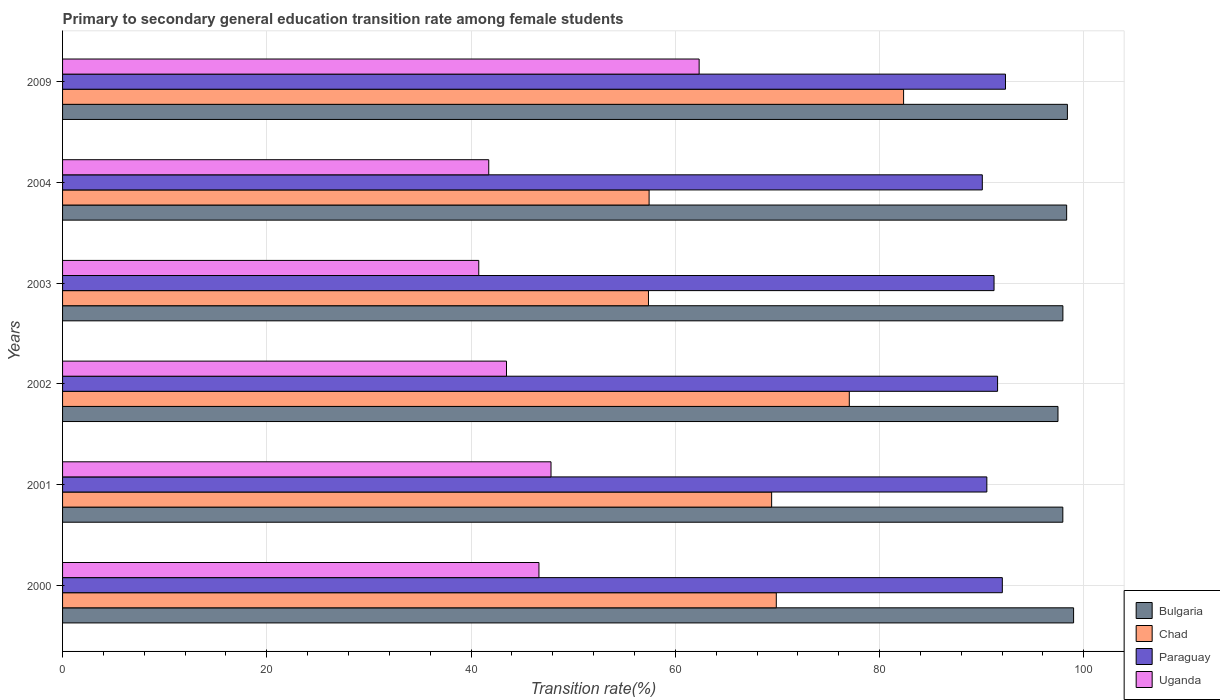How many different coloured bars are there?
Your answer should be very brief. 4. How many groups of bars are there?
Keep it short and to the point. 6. Are the number of bars on each tick of the Y-axis equal?
Keep it short and to the point. Yes. What is the label of the 2nd group of bars from the top?
Ensure brevity in your answer.  2004. In how many cases, is the number of bars for a given year not equal to the number of legend labels?
Give a very brief answer. 0. What is the transition rate in Paraguay in 2002?
Give a very brief answer. 91.55. Across all years, what is the maximum transition rate in Chad?
Make the answer very short. 82.35. Across all years, what is the minimum transition rate in Uganda?
Offer a terse response. 40.75. What is the total transition rate in Bulgaria in the graph?
Your answer should be compact. 589.07. What is the difference between the transition rate in Uganda in 2003 and that in 2004?
Give a very brief answer. -0.98. What is the difference between the transition rate in Paraguay in 2009 and the transition rate in Uganda in 2000?
Offer a very short reply. 45.68. What is the average transition rate in Chad per year?
Your response must be concise. 68.92. In the year 2001, what is the difference between the transition rate in Uganda and transition rate in Bulgaria?
Your answer should be compact. -50.12. What is the ratio of the transition rate in Chad in 2002 to that in 2004?
Offer a very short reply. 1.34. Is the transition rate in Chad in 2003 less than that in 2004?
Keep it short and to the point. Yes. What is the difference between the highest and the second highest transition rate in Bulgaria?
Offer a terse response. 0.61. What is the difference between the highest and the lowest transition rate in Bulgaria?
Provide a succinct answer. 1.53. In how many years, is the transition rate in Bulgaria greater than the average transition rate in Bulgaria taken over all years?
Make the answer very short. 3. Is the sum of the transition rate in Chad in 2001 and 2003 greater than the maximum transition rate in Bulgaria across all years?
Keep it short and to the point. Yes. Is it the case that in every year, the sum of the transition rate in Bulgaria and transition rate in Chad is greater than the sum of transition rate in Paraguay and transition rate in Uganda?
Offer a very short reply. No. What does the 4th bar from the top in 2004 represents?
Provide a short and direct response. Bulgaria. Is it the case that in every year, the sum of the transition rate in Uganda and transition rate in Bulgaria is greater than the transition rate in Paraguay?
Provide a short and direct response. Yes. How many bars are there?
Your response must be concise. 24. Are all the bars in the graph horizontal?
Make the answer very short. Yes. How many years are there in the graph?
Provide a succinct answer. 6. What is the difference between two consecutive major ticks on the X-axis?
Ensure brevity in your answer.  20. Does the graph contain grids?
Your answer should be compact. Yes. How many legend labels are there?
Your answer should be compact. 4. How are the legend labels stacked?
Give a very brief answer. Vertical. What is the title of the graph?
Provide a short and direct response. Primary to secondary general education transition rate among female students. Does "Saudi Arabia" appear as one of the legend labels in the graph?
Offer a terse response. No. What is the label or title of the X-axis?
Your answer should be very brief. Transition rate(%). What is the Transition rate(%) of Bulgaria in 2000?
Provide a succinct answer. 99. What is the Transition rate(%) in Chad in 2000?
Your answer should be compact. 69.89. What is the Transition rate(%) in Paraguay in 2000?
Your answer should be compact. 92.02. What is the Transition rate(%) in Uganda in 2000?
Your answer should be very brief. 46.65. What is the Transition rate(%) in Bulgaria in 2001?
Your answer should be compact. 97.94. What is the Transition rate(%) of Chad in 2001?
Provide a short and direct response. 69.43. What is the Transition rate(%) of Paraguay in 2001?
Your response must be concise. 90.5. What is the Transition rate(%) of Uganda in 2001?
Ensure brevity in your answer.  47.83. What is the Transition rate(%) of Bulgaria in 2002?
Your answer should be very brief. 97.47. What is the Transition rate(%) of Chad in 2002?
Ensure brevity in your answer.  77.03. What is the Transition rate(%) in Paraguay in 2002?
Offer a very short reply. 91.55. What is the Transition rate(%) in Uganda in 2002?
Make the answer very short. 43.47. What is the Transition rate(%) in Bulgaria in 2003?
Ensure brevity in your answer.  97.95. What is the Transition rate(%) in Chad in 2003?
Keep it short and to the point. 57.37. What is the Transition rate(%) of Paraguay in 2003?
Your response must be concise. 91.21. What is the Transition rate(%) of Uganda in 2003?
Ensure brevity in your answer.  40.75. What is the Transition rate(%) of Bulgaria in 2004?
Provide a short and direct response. 98.32. What is the Transition rate(%) in Chad in 2004?
Your answer should be compact. 57.43. What is the Transition rate(%) in Paraguay in 2004?
Your answer should be very brief. 90.06. What is the Transition rate(%) of Uganda in 2004?
Your answer should be very brief. 41.73. What is the Transition rate(%) of Bulgaria in 2009?
Your answer should be very brief. 98.39. What is the Transition rate(%) in Chad in 2009?
Keep it short and to the point. 82.35. What is the Transition rate(%) in Paraguay in 2009?
Give a very brief answer. 92.33. What is the Transition rate(%) in Uganda in 2009?
Keep it short and to the point. 62.33. Across all years, what is the maximum Transition rate(%) in Bulgaria?
Your answer should be compact. 99. Across all years, what is the maximum Transition rate(%) in Chad?
Your answer should be very brief. 82.35. Across all years, what is the maximum Transition rate(%) in Paraguay?
Provide a short and direct response. 92.33. Across all years, what is the maximum Transition rate(%) of Uganda?
Offer a very short reply. 62.33. Across all years, what is the minimum Transition rate(%) of Bulgaria?
Make the answer very short. 97.47. Across all years, what is the minimum Transition rate(%) in Chad?
Provide a succinct answer. 57.37. Across all years, what is the minimum Transition rate(%) of Paraguay?
Offer a very short reply. 90.06. Across all years, what is the minimum Transition rate(%) of Uganda?
Offer a very short reply. 40.75. What is the total Transition rate(%) in Bulgaria in the graph?
Your answer should be very brief. 589.07. What is the total Transition rate(%) in Chad in the graph?
Ensure brevity in your answer.  413.51. What is the total Transition rate(%) in Paraguay in the graph?
Provide a short and direct response. 547.67. What is the total Transition rate(%) in Uganda in the graph?
Your response must be concise. 282.76. What is the difference between the Transition rate(%) of Bulgaria in 2000 and that in 2001?
Give a very brief answer. 1.05. What is the difference between the Transition rate(%) of Chad in 2000 and that in 2001?
Provide a short and direct response. 0.46. What is the difference between the Transition rate(%) of Paraguay in 2000 and that in 2001?
Provide a succinct answer. 1.52. What is the difference between the Transition rate(%) in Uganda in 2000 and that in 2001?
Your response must be concise. -1.18. What is the difference between the Transition rate(%) in Bulgaria in 2000 and that in 2002?
Provide a succinct answer. 1.53. What is the difference between the Transition rate(%) in Chad in 2000 and that in 2002?
Provide a short and direct response. -7.15. What is the difference between the Transition rate(%) of Paraguay in 2000 and that in 2002?
Offer a very short reply. 0.46. What is the difference between the Transition rate(%) in Uganda in 2000 and that in 2002?
Your response must be concise. 3.18. What is the difference between the Transition rate(%) of Bulgaria in 2000 and that in 2003?
Ensure brevity in your answer.  1.05. What is the difference between the Transition rate(%) of Chad in 2000 and that in 2003?
Give a very brief answer. 12.52. What is the difference between the Transition rate(%) in Paraguay in 2000 and that in 2003?
Make the answer very short. 0.81. What is the difference between the Transition rate(%) in Uganda in 2000 and that in 2003?
Your answer should be compact. 5.89. What is the difference between the Transition rate(%) in Bulgaria in 2000 and that in 2004?
Make the answer very short. 0.68. What is the difference between the Transition rate(%) in Chad in 2000 and that in 2004?
Your response must be concise. 12.46. What is the difference between the Transition rate(%) of Paraguay in 2000 and that in 2004?
Provide a succinct answer. 1.96. What is the difference between the Transition rate(%) of Uganda in 2000 and that in 2004?
Your answer should be very brief. 4.92. What is the difference between the Transition rate(%) in Bulgaria in 2000 and that in 2009?
Provide a short and direct response. 0.61. What is the difference between the Transition rate(%) in Chad in 2000 and that in 2009?
Your answer should be very brief. -12.46. What is the difference between the Transition rate(%) in Paraguay in 2000 and that in 2009?
Make the answer very short. -0.31. What is the difference between the Transition rate(%) in Uganda in 2000 and that in 2009?
Your answer should be compact. -15.69. What is the difference between the Transition rate(%) of Bulgaria in 2001 and that in 2002?
Your answer should be very brief. 0.47. What is the difference between the Transition rate(%) in Chad in 2001 and that in 2002?
Provide a succinct answer. -7.6. What is the difference between the Transition rate(%) of Paraguay in 2001 and that in 2002?
Provide a succinct answer. -1.05. What is the difference between the Transition rate(%) of Uganda in 2001 and that in 2002?
Make the answer very short. 4.36. What is the difference between the Transition rate(%) of Bulgaria in 2001 and that in 2003?
Make the answer very short. -0.01. What is the difference between the Transition rate(%) in Chad in 2001 and that in 2003?
Give a very brief answer. 12.06. What is the difference between the Transition rate(%) in Paraguay in 2001 and that in 2003?
Offer a terse response. -0.7. What is the difference between the Transition rate(%) in Uganda in 2001 and that in 2003?
Provide a succinct answer. 7.07. What is the difference between the Transition rate(%) of Bulgaria in 2001 and that in 2004?
Keep it short and to the point. -0.37. What is the difference between the Transition rate(%) of Chad in 2001 and that in 2004?
Your response must be concise. 12. What is the difference between the Transition rate(%) in Paraguay in 2001 and that in 2004?
Your answer should be compact. 0.44. What is the difference between the Transition rate(%) of Uganda in 2001 and that in 2004?
Ensure brevity in your answer.  6.1. What is the difference between the Transition rate(%) in Bulgaria in 2001 and that in 2009?
Offer a very short reply. -0.45. What is the difference between the Transition rate(%) of Chad in 2001 and that in 2009?
Provide a short and direct response. -12.92. What is the difference between the Transition rate(%) of Paraguay in 2001 and that in 2009?
Make the answer very short. -1.82. What is the difference between the Transition rate(%) of Uganda in 2001 and that in 2009?
Your answer should be very brief. -14.5. What is the difference between the Transition rate(%) in Bulgaria in 2002 and that in 2003?
Your response must be concise. -0.48. What is the difference between the Transition rate(%) in Chad in 2002 and that in 2003?
Keep it short and to the point. 19.66. What is the difference between the Transition rate(%) of Paraguay in 2002 and that in 2003?
Provide a succinct answer. 0.35. What is the difference between the Transition rate(%) in Uganda in 2002 and that in 2003?
Offer a very short reply. 2.72. What is the difference between the Transition rate(%) in Bulgaria in 2002 and that in 2004?
Offer a terse response. -0.85. What is the difference between the Transition rate(%) of Chad in 2002 and that in 2004?
Provide a short and direct response. 19.6. What is the difference between the Transition rate(%) in Paraguay in 2002 and that in 2004?
Make the answer very short. 1.49. What is the difference between the Transition rate(%) of Uganda in 2002 and that in 2004?
Keep it short and to the point. 1.74. What is the difference between the Transition rate(%) of Bulgaria in 2002 and that in 2009?
Offer a terse response. -0.92. What is the difference between the Transition rate(%) of Chad in 2002 and that in 2009?
Ensure brevity in your answer.  -5.32. What is the difference between the Transition rate(%) of Paraguay in 2002 and that in 2009?
Your response must be concise. -0.77. What is the difference between the Transition rate(%) in Uganda in 2002 and that in 2009?
Your response must be concise. -18.86. What is the difference between the Transition rate(%) of Bulgaria in 2003 and that in 2004?
Provide a short and direct response. -0.37. What is the difference between the Transition rate(%) of Chad in 2003 and that in 2004?
Your answer should be compact. -0.06. What is the difference between the Transition rate(%) in Paraguay in 2003 and that in 2004?
Your answer should be compact. 1.15. What is the difference between the Transition rate(%) in Uganda in 2003 and that in 2004?
Provide a succinct answer. -0.98. What is the difference between the Transition rate(%) in Bulgaria in 2003 and that in 2009?
Provide a succinct answer. -0.44. What is the difference between the Transition rate(%) of Chad in 2003 and that in 2009?
Your response must be concise. -24.98. What is the difference between the Transition rate(%) of Paraguay in 2003 and that in 2009?
Make the answer very short. -1.12. What is the difference between the Transition rate(%) in Uganda in 2003 and that in 2009?
Offer a terse response. -21.58. What is the difference between the Transition rate(%) of Bulgaria in 2004 and that in 2009?
Provide a succinct answer. -0.07. What is the difference between the Transition rate(%) in Chad in 2004 and that in 2009?
Your answer should be compact. -24.92. What is the difference between the Transition rate(%) in Paraguay in 2004 and that in 2009?
Keep it short and to the point. -2.27. What is the difference between the Transition rate(%) of Uganda in 2004 and that in 2009?
Offer a terse response. -20.6. What is the difference between the Transition rate(%) of Bulgaria in 2000 and the Transition rate(%) of Chad in 2001?
Ensure brevity in your answer.  29.57. What is the difference between the Transition rate(%) in Bulgaria in 2000 and the Transition rate(%) in Paraguay in 2001?
Keep it short and to the point. 8.49. What is the difference between the Transition rate(%) in Bulgaria in 2000 and the Transition rate(%) in Uganda in 2001?
Provide a short and direct response. 51.17. What is the difference between the Transition rate(%) in Chad in 2000 and the Transition rate(%) in Paraguay in 2001?
Give a very brief answer. -20.62. What is the difference between the Transition rate(%) of Chad in 2000 and the Transition rate(%) of Uganda in 2001?
Your answer should be compact. 22.06. What is the difference between the Transition rate(%) in Paraguay in 2000 and the Transition rate(%) in Uganda in 2001?
Keep it short and to the point. 44.19. What is the difference between the Transition rate(%) of Bulgaria in 2000 and the Transition rate(%) of Chad in 2002?
Offer a very short reply. 21.96. What is the difference between the Transition rate(%) of Bulgaria in 2000 and the Transition rate(%) of Paraguay in 2002?
Give a very brief answer. 7.44. What is the difference between the Transition rate(%) in Bulgaria in 2000 and the Transition rate(%) in Uganda in 2002?
Keep it short and to the point. 55.53. What is the difference between the Transition rate(%) of Chad in 2000 and the Transition rate(%) of Paraguay in 2002?
Provide a succinct answer. -21.67. What is the difference between the Transition rate(%) in Chad in 2000 and the Transition rate(%) in Uganda in 2002?
Your answer should be very brief. 26.42. What is the difference between the Transition rate(%) of Paraguay in 2000 and the Transition rate(%) of Uganda in 2002?
Offer a terse response. 48.55. What is the difference between the Transition rate(%) in Bulgaria in 2000 and the Transition rate(%) in Chad in 2003?
Your answer should be very brief. 41.63. What is the difference between the Transition rate(%) of Bulgaria in 2000 and the Transition rate(%) of Paraguay in 2003?
Provide a short and direct response. 7.79. What is the difference between the Transition rate(%) of Bulgaria in 2000 and the Transition rate(%) of Uganda in 2003?
Offer a terse response. 58.24. What is the difference between the Transition rate(%) in Chad in 2000 and the Transition rate(%) in Paraguay in 2003?
Your answer should be compact. -21.32. What is the difference between the Transition rate(%) of Chad in 2000 and the Transition rate(%) of Uganda in 2003?
Keep it short and to the point. 29.13. What is the difference between the Transition rate(%) in Paraguay in 2000 and the Transition rate(%) in Uganda in 2003?
Provide a succinct answer. 51.27. What is the difference between the Transition rate(%) in Bulgaria in 2000 and the Transition rate(%) in Chad in 2004?
Provide a short and direct response. 41.57. What is the difference between the Transition rate(%) in Bulgaria in 2000 and the Transition rate(%) in Paraguay in 2004?
Your answer should be compact. 8.94. What is the difference between the Transition rate(%) of Bulgaria in 2000 and the Transition rate(%) of Uganda in 2004?
Ensure brevity in your answer.  57.27. What is the difference between the Transition rate(%) in Chad in 2000 and the Transition rate(%) in Paraguay in 2004?
Offer a very short reply. -20.17. What is the difference between the Transition rate(%) in Chad in 2000 and the Transition rate(%) in Uganda in 2004?
Offer a terse response. 28.16. What is the difference between the Transition rate(%) of Paraguay in 2000 and the Transition rate(%) of Uganda in 2004?
Offer a terse response. 50.29. What is the difference between the Transition rate(%) of Bulgaria in 2000 and the Transition rate(%) of Chad in 2009?
Provide a short and direct response. 16.65. What is the difference between the Transition rate(%) in Bulgaria in 2000 and the Transition rate(%) in Paraguay in 2009?
Provide a succinct answer. 6.67. What is the difference between the Transition rate(%) in Bulgaria in 2000 and the Transition rate(%) in Uganda in 2009?
Your answer should be compact. 36.67. What is the difference between the Transition rate(%) of Chad in 2000 and the Transition rate(%) of Paraguay in 2009?
Give a very brief answer. -22.44. What is the difference between the Transition rate(%) in Chad in 2000 and the Transition rate(%) in Uganda in 2009?
Your response must be concise. 7.56. What is the difference between the Transition rate(%) of Paraguay in 2000 and the Transition rate(%) of Uganda in 2009?
Give a very brief answer. 29.69. What is the difference between the Transition rate(%) of Bulgaria in 2001 and the Transition rate(%) of Chad in 2002?
Give a very brief answer. 20.91. What is the difference between the Transition rate(%) of Bulgaria in 2001 and the Transition rate(%) of Paraguay in 2002?
Your answer should be compact. 6.39. What is the difference between the Transition rate(%) in Bulgaria in 2001 and the Transition rate(%) in Uganda in 2002?
Your answer should be compact. 54.47. What is the difference between the Transition rate(%) of Chad in 2001 and the Transition rate(%) of Paraguay in 2002?
Your response must be concise. -22.12. What is the difference between the Transition rate(%) of Chad in 2001 and the Transition rate(%) of Uganda in 2002?
Make the answer very short. 25.96. What is the difference between the Transition rate(%) in Paraguay in 2001 and the Transition rate(%) in Uganda in 2002?
Offer a terse response. 47.03. What is the difference between the Transition rate(%) in Bulgaria in 2001 and the Transition rate(%) in Chad in 2003?
Keep it short and to the point. 40.57. What is the difference between the Transition rate(%) of Bulgaria in 2001 and the Transition rate(%) of Paraguay in 2003?
Provide a short and direct response. 6.74. What is the difference between the Transition rate(%) of Bulgaria in 2001 and the Transition rate(%) of Uganda in 2003?
Offer a very short reply. 57.19. What is the difference between the Transition rate(%) of Chad in 2001 and the Transition rate(%) of Paraguay in 2003?
Ensure brevity in your answer.  -21.78. What is the difference between the Transition rate(%) of Chad in 2001 and the Transition rate(%) of Uganda in 2003?
Ensure brevity in your answer.  28.68. What is the difference between the Transition rate(%) of Paraguay in 2001 and the Transition rate(%) of Uganda in 2003?
Provide a succinct answer. 49.75. What is the difference between the Transition rate(%) in Bulgaria in 2001 and the Transition rate(%) in Chad in 2004?
Make the answer very short. 40.51. What is the difference between the Transition rate(%) in Bulgaria in 2001 and the Transition rate(%) in Paraguay in 2004?
Give a very brief answer. 7.88. What is the difference between the Transition rate(%) of Bulgaria in 2001 and the Transition rate(%) of Uganda in 2004?
Provide a short and direct response. 56.21. What is the difference between the Transition rate(%) in Chad in 2001 and the Transition rate(%) in Paraguay in 2004?
Offer a terse response. -20.63. What is the difference between the Transition rate(%) of Chad in 2001 and the Transition rate(%) of Uganda in 2004?
Provide a succinct answer. 27.7. What is the difference between the Transition rate(%) in Paraguay in 2001 and the Transition rate(%) in Uganda in 2004?
Make the answer very short. 48.77. What is the difference between the Transition rate(%) in Bulgaria in 2001 and the Transition rate(%) in Chad in 2009?
Offer a very short reply. 15.59. What is the difference between the Transition rate(%) of Bulgaria in 2001 and the Transition rate(%) of Paraguay in 2009?
Offer a terse response. 5.62. What is the difference between the Transition rate(%) in Bulgaria in 2001 and the Transition rate(%) in Uganda in 2009?
Offer a terse response. 35.61. What is the difference between the Transition rate(%) in Chad in 2001 and the Transition rate(%) in Paraguay in 2009?
Your answer should be compact. -22.9. What is the difference between the Transition rate(%) of Chad in 2001 and the Transition rate(%) of Uganda in 2009?
Offer a terse response. 7.1. What is the difference between the Transition rate(%) in Paraguay in 2001 and the Transition rate(%) in Uganda in 2009?
Keep it short and to the point. 28.17. What is the difference between the Transition rate(%) of Bulgaria in 2002 and the Transition rate(%) of Chad in 2003?
Give a very brief answer. 40.1. What is the difference between the Transition rate(%) of Bulgaria in 2002 and the Transition rate(%) of Paraguay in 2003?
Ensure brevity in your answer.  6.26. What is the difference between the Transition rate(%) in Bulgaria in 2002 and the Transition rate(%) in Uganda in 2003?
Provide a short and direct response. 56.72. What is the difference between the Transition rate(%) of Chad in 2002 and the Transition rate(%) of Paraguay in 2003?
Give a very brief answer. -14.17. What is the difference between the Transition rate(%) of Chad in 2002 and the Transition rate(%) of Uganda in 2003?
Keep it short and to the point. 36.28. What is the difference between the Transition rate(%) in Paraguay in 2002 and the Transition rate(%) in Uganda in 2003?
Keep it short and to the point. 50.8. What is the difference between the Transition rate(%) in Bulgaria in 2002 and the Transition rate(%) in Chad in 2004?
Your answer should be compact. 40.04. What is the difference between the Transition rate(%) of Bulgaria in 2002 and the Transition rate(%) of Paraguay in 2004?
Your response must be concise. 7.41. What is the difference between the Transition rate(%) in Bulgaria in 2002 and the Transition rate(%) in Uganda in 2004?
Keep it short and to the point. 55.74. What is the difference between the Transition rate(%) in Chad in 2002 and the Transition rate(%) in Paraguay in 2004?
Offer a very short reply. -13.03. What is the difference between the Transition rate(%) of Chad in 2002 and the Transition rate(%) of Uganda in 2004?
Your response must be concise. 35.3. What is the difference between the Transition rate(%) in Paraguay in 2002 and the Transition rate(%) in Uganda in 2004?
Your response must be concise. 49.82. What is the difference between the Transition rate(%) of Bulgaria in 2002 and the Transition rate(%) of Chad in 2009?
Give a very brief answer. 15.12. What is the difference between the Transition rate(%) in Bulgaria in 2002 and the Transition rate(%) in Paraguay in 2009?
Ensure brevity in your answer.  5.14. What is the difference between the Transition rate(%) of Bulgaria in 2002 and the Transition rate(%) of Uganda in 2009?
Give a very brief answer. 35.14. What is the difference between the Transition rate(%) in Chad in 2002 and the Transition rate(%) in Paraguay in 2009?
Provide a succinct answer. -15.29. What is the difference between the Transition rate(%) in Chad in 2002 and the Transition rate(%) in Uganda in 2009?
Make the answer very short. 14.7. What is the difference between the Transition rate(%) in Paraguay in 2002 and the Transition rate(%) in Uganda in 2009?
Make the answer very short. 29.22. What is the difference between the Transition rate(%) in Bulgaria in 2003 and the Transition rate(%) in Chad in 2004?
Your answer should be very brief. 40.52. What is the difference between the Transition rate(%) in Bulgaria in 2003 and the Transition rate(%) in Paraguay in 2004?
Provide a short and direct response. 7.89. What is the difference between the Transition rate(%) of Bulgaria in 2003 and the Transition rate(%) of Uganda in 2004?
Make the answer very short. 56.22. What is the difference between the Transition rate(%) in Chad in 2003 and the Transition rate(%) in Paraguay in 2004?
Provide a short and direct response. -32.69. What is the difference between the Transition rate(%) in Chad in 2003 and the Transition rate(%) in Uganda in 2004?
Offer a terse response. 15.64. What is the difference between the Transition rate(%) of Paraguay in 2003 and the Transition rate(%) of Uganda in 2004?
Make the answer very short. 49.48. What is the difference between the Transition rate(%) of Bulgaria in 2003 and the Transition rate(%) of Chad in 2009?
Offer a terse response. 15.6. What is the difference between the Transition rate(%) in Bulgaria in 2003 and the Transition rate(%) in Paraguay in 2009?
Provide a succinct answer. 5.62. What is the difference between the Transition rate(%) of Bulgaria in 2003 and the Transition rate(%) of Uganda in 2009?
Your answer should be compact. 35.62. What is the difference between the Transition rate(%) in Chad in 2003 and the Transition rate(%) in Paraguay in 2009?
Make the answer very short. -34.96. What is the difference between the Transition rate(%) in Chad in 2003 and the Transition rate(%) in Uganda in 2009?
Your response must be concise. -4.96. What is the difference between the Transition rate(%) of Paraguay in 2003 and the Transition rate(%) of Uganda in 2009?
Offer a terse response. 28.88. What is the difference between the Transition rate(%) in Bulgaria in 2004 and the Transition rate(%) in Chad in 2009?
Keep it short and to the point. 15.97. What is the difference between the Transition rate(%) of Bulgaria in 2004 and the Transition rate(%) of Paraguay in 2009?
Offer a very short reply. 5.99. What is the difference between the Transition rate(%) of Bulgaria in 2004 and the Transition rate(%) of Uganda in 2009?
Your answer should be very brief. 35.99. What is the difference between the Transition rate(%) of Chad in 2004 and the Transition rate(%) of Paraguay in 2009?
Give a very brief answer. -34.9. What is the difference between the Transition rate(%) of Chad in 2004 and the Transition rate(%) of Uganda in 2009?
Give a very brief answer. -4.9. What is the difference between the Transition rate(%) in Paraguay in 2004 and the Transition rate(%) in Uganda in 2009?
Provide a succinct answer. 27.73. What is the average Transition rate(%) of Bulgaria per year?
Make the answer very short. 98.18. What is the average Transition rate(%) of Chad per year?
Offer a very short reply. 68.92. What is the average Transition rate(%) of Paraguay per year?
Ensure brevity in your answer.  91.28. What is the average Transition rate(%) of Uganda per year?
Your answer should be very brief. 47.13. In the year 2000, what is the difference between the Transition rate(%) of Bulgaria and Transition rate(%) of Chad?
Offer a terse response. 29.11. In the year 2000, what is the difference between the Transition rate(%) of Bulgaria and Transition rate(%) of Paraguay?
Provide a succinct answer. 6.98. In the year 2000, what is the difference between the Transition rate(%) of Bulgaria and Transition rate(%) of Uganda?
Provide a short and direct response. 52.35. In the year 2000, what is the difference between the Transition rate(%) in Chad and Transition rate(%) in Paraguay?
Ensure brevity in your answer.  -22.13. In the year 2000, what is the difference between the Transition rate(%) in Chad and Transition rate(%) in Uganda?
Provide a succinct answer. 23.24. In the year 2000, what is the difference between the Transition rate(%) in Paraguay and Transition rate(%) in Uganda?
Give a very brief answer. 45.37. In the year 2001, what is the difference between the Transition rate(%) in Bulgaria and Transition rate(%) in Chad?
Your response must be concise. 28.51. In the year 2001, what is the difference between the Transition rate(%) in Bulgaria and Transition rate(%) in Paraguay?
Make the answer very short. 7.44. In the year 2001, what is the difference between the Transition rate(%) of Bulgaria and Transition rate(%) of Uganda?
Offer a terse response. 50.12. In the year 2001, what is the difference between the Transition rate(%) in Chad and Transition rate(%) in Paraguay?
Provide a short and direct response. -21.07. In the year 2001, what is the difference between the Transition rate(%) in Chad and Transition rate(%) in Uganda?
Make the answer very short. 21.6. In the year 2001, what is the difference between the Transition rate(%) in Paraguay and Transition rate(%) in Uganda?
Your answer should be very brief. 42.68. In the year 2002, what is the difference between the Transition rate(%) in Bulgaria and Transition rate(%) in Chad?
Offer a terse response. 20.43. In the year 2002, what is the difference between the Transition rate(%) in Bulgaria and Transition rate(%) in Paraguay?
Offer a very short reply. 5.91. In the year 2002, what is the difference between the Transition rate(%) in Bulgaria and Transition rate(%) in Uganda?
Give a very brief answer. 54. In the year 2002, what is the difference between the Transition rate(%) in Chad and Transition rate(%) in Paraguay?
Give a very brief answer. -14.52. In the year 2002, what is the difference between the Transition rate(%) of Chad and Transition rate(%) of Uganda?
Offer a terse response. 33.57. In the year 2002, what is the difference between the Transition rate(%) of Paraguay and Transition rate(%) of Uganda?
Keep it short and to the point. 48.09. In the year 2003, what is the difference between the Transition rate(%) in Bulgaria and Transition rate(%) in Chad?
Make the answer very short. 40.58. In the year 2003, what is the difference between the Transition rate(%) in Bulgaria and Transition rate(%) in Paraguay?
Your answer should be compact. 6.74. In the year 2003, what is the difference between the Transition rate(%) in Bulgaria and Transition rate(%) in Uganda?
Provide a succinct answer. 57.2. In the year 2003, what is the difference between the Transition rate(%) of Chad and Transition rate(%) of Paraguay?
Keep it short and to the point. -33.84. In the year 2003, what is the difference between the Transition rate(%) in Chad and Transition rate(%) in Uganda?
Offer a very short reply. 16.62. In the year 2003, what is the difference between the Transition rate(%) in Paraguay and Transition rate(%) in Uganda?
Provide a short and direct response. 50.45. In the year 2004, what is the difference between the Transition rate(%) of Bulgaria and Transition rate(%) of Chad?
Provide a succinct answer. 40.89. In the year 2004, what is the difference between the Transition rate(%) in Bulgaria and Transition rate(%) in Paraguay?
Offer a very short reply. 8.26. In the year 2004, what is the difference between the Transition rate(%) in Bulgaria and Transition rate(%) in Uganda?
Your answer should be very brief. 56.59. In the year 2004, what is the difference between the Transition rate(%) of Chad and Transition rate(%) of Paraguay?
Keep it short and to the point. -32.63. In the year 2004, what is the difference between the Transition rate(%) in Chad and Transition rate(%) in Uganda?
Offer a terse response. 15.7. In the year 2004, what is the difference between the Transition rate(%) of Paraguay and Transition rate(%) of Uganda?
Provide a succinct answer. 48.33. In the year 2009, what is the difference between the Transition rate(%) in Bulgaria and Transition rate(%) in Chad?
Offer a terse response. 16.04. In the year 2009, what is the difference between the Transition rate(%) of Bulgaria and Transition rate(%) of Paraguay?
Provide a succinct answer. 6.06. In the year 2009, what is the difference between the Transition rate(%) in Bulgaria and Transition rate(%) in Uganda?
Your answer should be very brief. 36.06. In the year 2009, what is the difference between the Transition rate(%) of Chad and Transition rate(%) of Paraguay?
Keep it short and to the point. -9.98. In the year 2009, what is the difference between the Transition rate(%) in Chad and Transition rate(%) in Uganda?
Offer a terse response. 20.02. In the year 2009, what is the difference between the Transition rate(%) in Paraguay and Transition rate(%) in Uganda?
Offer a terse response. 30. What is the ratio of the Transition rate(%) in Bulgaria in 2000 to that in 2001?
Provide a succinct answer. 1.01. What is the ratio of the Transition rate(%) of Chad in 2000 to that in 2001?
Your response must be concise. 1.01. What is the ratio of the Transition rate(%) of Paraguay in 2000 to that in 2001?
Ensure brevity in your answer.  1.02. What is the ratio of the Transition rate(%) in Uganda in 2000 to that in 2001?
Offer a terse response. 0.98. What is the ratio of the Transition rate(%) in Bulgaria in 2000 to that in 2002?
Make the answer very short. 1.02. What is the ratio of the Transition rate(%) in Chad in 2000 to that in 2002?
Give a very brief answer. 0.91. What is the ratio of the Transition rate(%) of Uganda in 2000 to that in 2002?
Provide a succinct answer. 1.07. What is the ratio of the Transition rate(%) in Bulgaria in 2000 to that in 2003?
Your answer should be very brief. 1.01. What is the ratio of the Transition rate(%) in Chad in 2000 to that in 2003?
Give a very brief answer. 1.22. What is the ratio of the Transition rate(%) in Paraguay in 2000 to that in 2003?
Provide a succinct answer. 1.01. What is the ratio of the Transition rate(%) in Uganda in 2000 to that in 2003?
Your answer should be very brief. 1.14. What is the ratio of the Transition rate(%) in Chad in 2000 to that in 2004?
Keep it short and to the point. 1.22. What is the ratio of the Transition rate(%) of Paraguay in 2000 to that in 2004?
Your answer should be compact. 1.02. What is the ratio of the Transition rate(%) of Uganda in 2000 to that in 2004?
Your answer should be compact. 1.12. What is the ratio of the Transition rate(%) in Chad in 2000 to that in 2009?
Offer a terse response. 0.85. What is the ratio of the Transition rate(%) in Paraguay in 2000 to that in 2009?
Make the answer very short. 1. What is the ratio of the Transition rate(%) of Uganda in 2000 to that in 2009?
Provide a short and direct response. 0.75. What is the ratio of the Transition rate(%) of Chad in 2001 to that in 2002?
Your answer should be very brief. 0.9. What is the ratio of the Transition rate(%) in Uganda in 2001 to that in 2002?
Your answer should be compact. 1.1. What is the ratio of the Transition rate(%) of Bulgaria in 2001 to that in 2003?
Your response must be concise. 1. What is the ratio of the Transition rate(%) in Chad in 2001 to that in 2003?
Ensure brevity in your answer.  1.21. What is the ratio of the Transition rate(%) in Uganda in 2001 to that in 2003?
Give a very brief answer. 1.17. What is the ratio of the Transition rate(%) in Bulgaria in 2001 to that in 2004?
Your response must be concise. 1. What is the ratio of the Transition rate(%) in Chad in 2001 to that in 2004?
Make the answer very short. 1.21. What is the ratio of the Transition rate(%) in Paraguay in 2001 to that in 2004?
Your answer should be very brief. 1. What is the ratio of the Transition rate(%) of Uganda in 2001 to that in 2004?
Your answer should be compact. 1.15. What is the ratio of the Transition rate(%) in Bulgaria in 2001 to that in 2009?
Provide a short and direct response. 1. What is the ratio of the Transition rate(%) of Chad in 2001 to that in 2009?
Give a very brief answer. 0.84. What is the ratio of the Transition rate(%) in Paraguay in 2001 to that in 2009?
Provide a succinct answer. 0.98. What is the ratio of the Transition rate(%) in Uganda in 2001 to that in 2009?
Offer a terse response. 0.77. What is the ratio of the Transition rate(%) of Bulgaria in 2002 to that in 2003?
Ensure brevity in your answer.  1. What is the ratio of the Transition rate(%) in Chad in 2002 to that in 2003?
Offer a very short reply. 1.34. What is the ratio of the Transition rate(%) of Uganda in 2002 to that in 2003?
Your answer should be compact. 1.07. What is the ratio of the Transition rate(%) of Chad in 2002 to that in 2004?
Provide a short and direct response. 1.34. What is the ratio of the Transition rate(%) in Paraguay in 2002 to that in 2004?
Make the answer very short. 1.02. What is the ratio of the Transition rate(%) in Uganda in 2002 to that in 2004?
Offer a very short reply. 1.04. What is the ratio of the Transition rate(%) in Bulgaria in 2002 to that in 2009?
Your response must be concise. 0.99. What is the ratio of the Transition rate(%) of Chad in 2002 to that in 2009?
Offer a terse response. 0.94. What is the ratio of the Transition rate(%) in Uganda in 2002 to that in 2009?
Provide a succinct answer. 0.7. What is the ratio of the Transition rate(%) of Chad in 2003 to that in 2004?
Ensure brevity in your answer.  1. What is the ratio of the Transition rate(%) of Paraguay in 2003 to that in 2004?
Your answer should be compact. 1.01. What is the ratio of the Transition rate(%) of Uganda in 2003 to that in 2004?
Provide a succinct answer. 0.98. What is the ratio of the Transition rate(%) in Bulgaria in 2003 to that in 2009?
Ensure brevity in your answer.  1. What is the ratio of the Transition rate(%) in Chad in 2003 to that in 2009?
Offer a very short reply. 0.7. What is the ratio of the Transition rate(%) in Paraguay in 2003 to that in 2009?
Offer a terse response. 0.99. What is the ratio of the Transition rate(%) in Uganda in 2003 to that in 2009?
Make the answer very short. 0.65. What is the ratio of the Transition rate(%) in Bulgaria in 2004 to that in 2009?
Make the answer very short. 1. What is the ratio of the Transition rate(%) of Chad in 2004 to that in 2009?
Your answer should be very brief. 0.7. What is the ratio of the Transition rate(%) of Paraguay in 2004 to that in 2009?
Provide a succinct answer. 0.98. What is the ratio of the Transition rate(%) in Uganda in 2004 to that in 2009?
Give a very brief answer. 0.67. What is the difference between the highest and the second highest Transition rate(%) of Bulgaria?
Your response must be concise. 0.61. What is the difference between the highest and the second highest Transition rate(%) in Chad?
Keep it short and to the point. 5.32. What is the difference between the highest and the second highest Transition rate(%) in Paraguay?
Offer a terse response. 0.31. What is the difference between the highest and the second highest Transition rate(%) in Uganda?
Make the answer very short. 14.5. What is the difference between the highest and the lowest Transition rate(%) of Bulgaria?
Keep it short and to the point. 1.53. What is the difference between the highest and the lowest Transition rate(%) in Chad?
Provide a short and direct response. 24.98. What is the difference between the highest and the lowest Transition rate(%) of Paraguay?
Your answer should be compact. 2.27. What is the difference between the highest and the lowest Transition rate(%) of Uganda?
Your response must be concise. 21.58. 